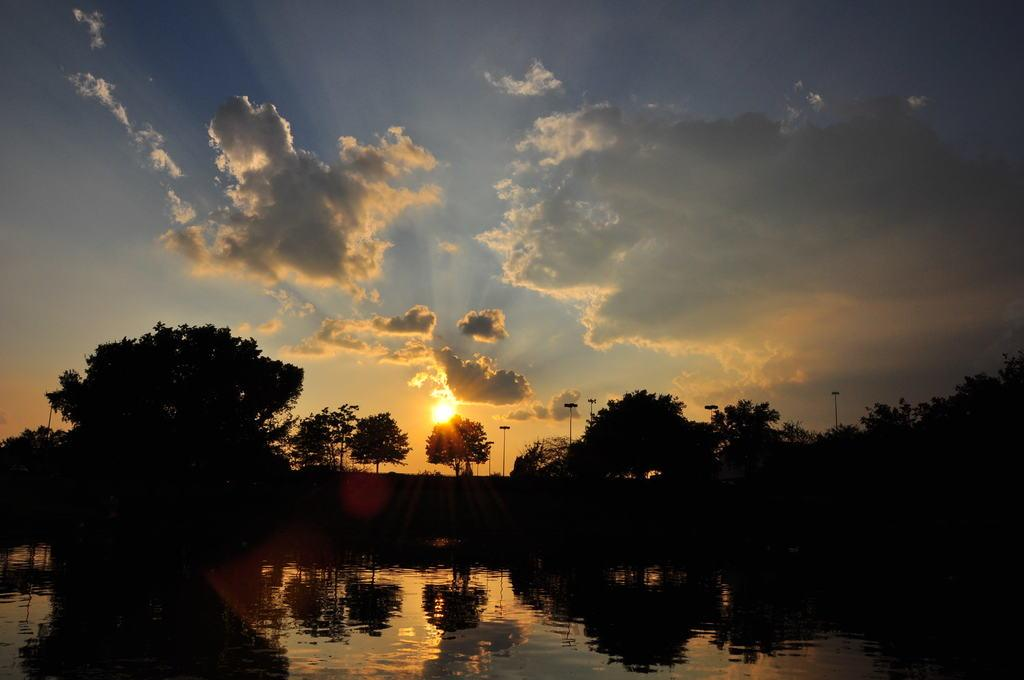What is the primary element visible in the image? There is water in the image. What type of vegetation can be seen in the image? There are trees in the image. What structures are present in the image? There are poles in the image. What can be seen in the background of the image? The sky is visible in the background of the image. What is the weather like in the image? The presence of clouds in the sky suggests that it might be partly cloudy. What type of head can be seen blowing an alarm in the image? There is no head or alarm present in the image. 